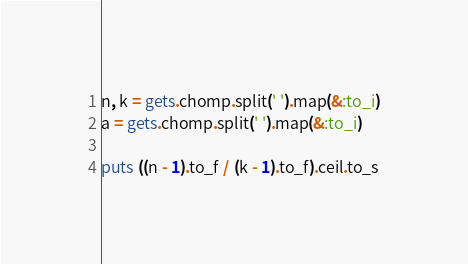<code> <loc_0><loc_0><loc_500><loc_500><_Ruby_>n, k = gets.chomp.split(' ').map(&:to_i)
a = gets.chomp.split(' ').map(&:to_i)
 
puts ((n - 1).to_f / (k - 1).to_f).ceil.to_s</code> 